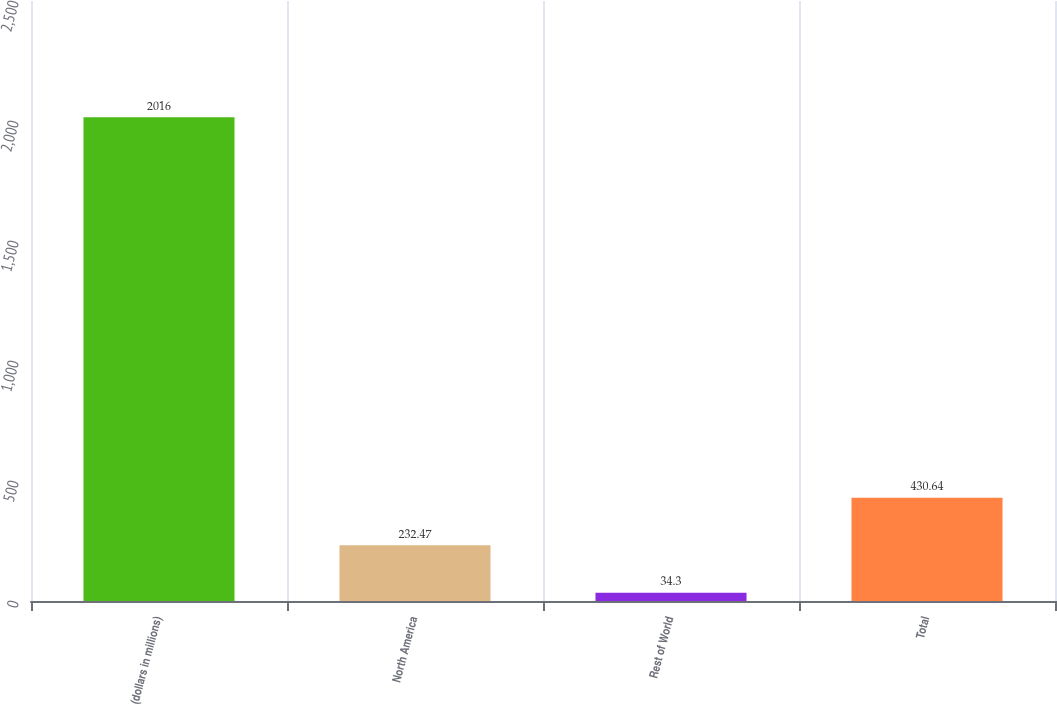<chart> <loc_0><loc_0><loc_500><loc_500><bar_chart><fcel>(dollars in millions)<fcel>North America<fcel>Rest of World<fcel>Total<nl><fcel>2016<fcel>232.47<fcel>34.3<fcel>430.64<nl></chart> 